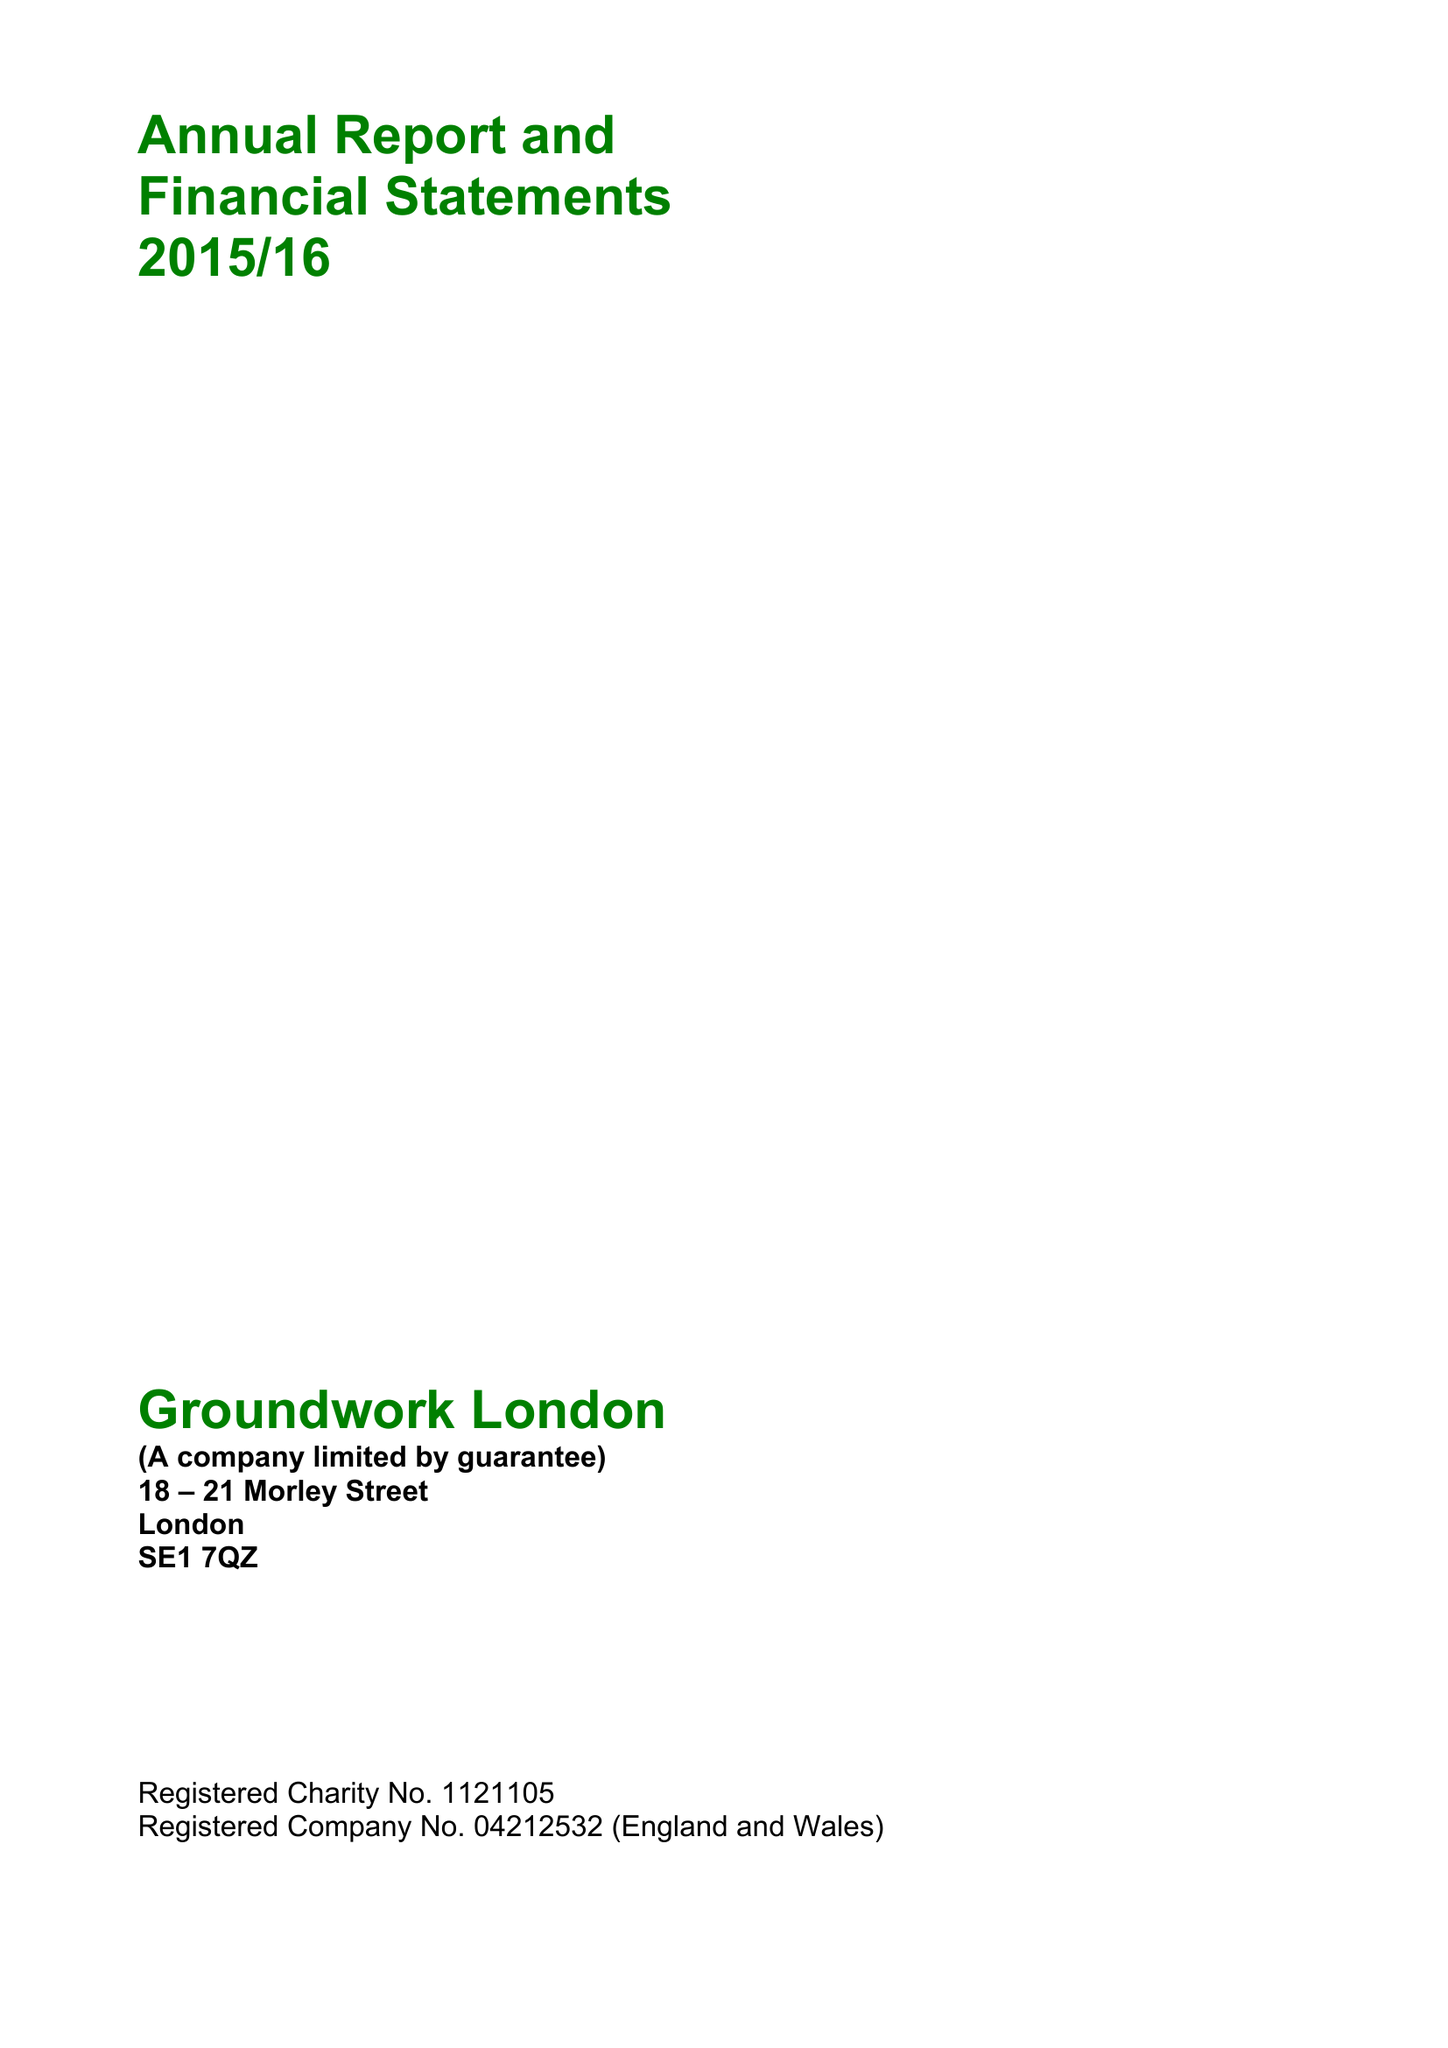What is the value for the address__street_line?
Answer the question using a single word or phrase. 18-21 MORLEY STREET 